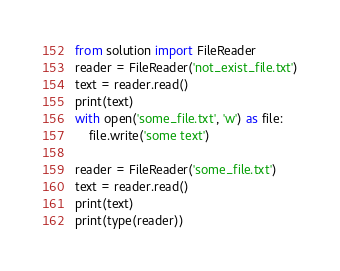<code> <loc_0><loc_0><loc_500><loc_500><_Python_>from solution import FileReader
reader = FileReader('not_exist_file.txt')
text = reader.read()
print(text)
with open('some_file.txt', 'w') as file:
    file.write('some text')

reader = FileReader('some_file.txt')
text = reader.read()
print(text)
print(type(reader))</code> 